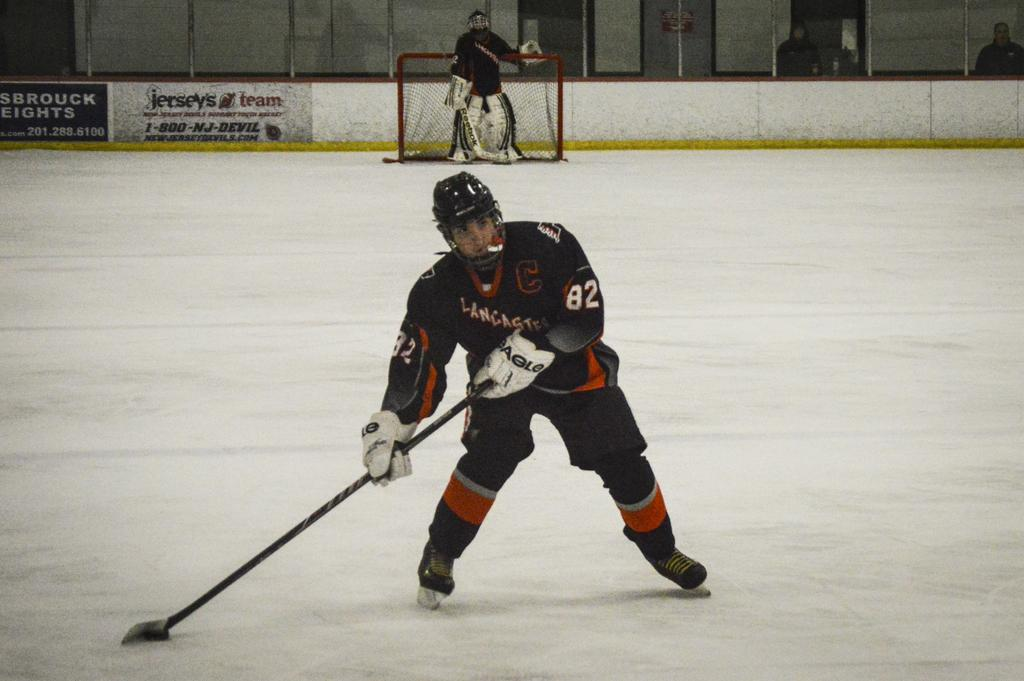What is the man in the center of the image holding? The man in the center of the image is holding a stick. What can be seen in the background of the image? In the background of the image, there are people, a wall, a net, and boards. What is the ground covered with at the bottom of the image? The ground is covered with snow at the bottom of the image. Can you see any fairies flying around the man holding the stick in the image? No, there are no fairies visible in the image. What type of cheese is being used to hold the net in place in the image? There is no cheese present in the image; the net is held up by other means. 